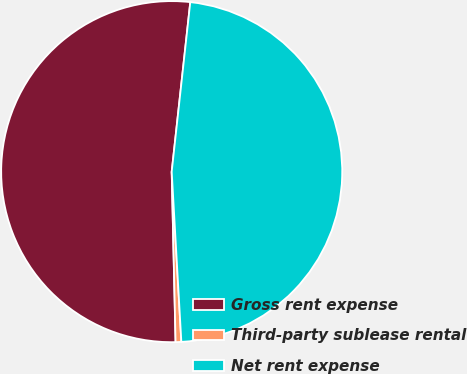<chart> <loc_0><loc_0><loc_500><loc_500><pie_chart><fcel>Gross rent expense<fcel>Third-party sublease rental<fcel>Net rent expense<nl><fcel>52.1%<fcel>0.54%<fcel>47.36%<nl></chart> 